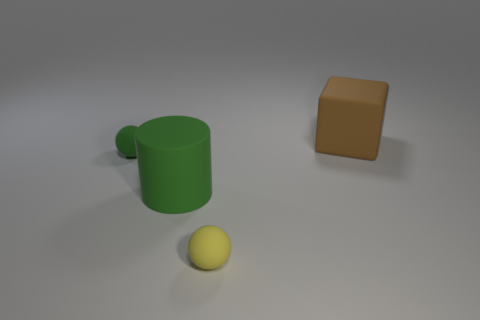What is the shape of the thing that is the same color as the matte cylinder?
Provide a succinct answer. Sphere. Are there any other tiny objects of the same shape as the small yellow rubber thing?
Your response must be concise. Yes. What is the shape of the thing that is the same size as the yellow sphere?
Make the answer very short. Sphere. There is a big cylinder; does it have the same color as the tiny matte object on the left side of the big green rubber thing?
Keep it short and to the point. Yes. There is a large matte thing left of the brown matte block; how many cubes are to the right of it?
Provide a succinct answer. 1. There is a object that is both in front of the large cube and on the right side of the large rubber cylinder; what is its size?
Offer a very short reply. Small. Are there any other spheres of the same size as the green rubber ball?
Provide a short and direct response. Yes. Is the number of cubes left of the tiny yellow ball greater than the number of yellow spheres right of the brown object?
Make the answer very short. No. Is the material of the brown cube the same as the small yellow object to the right of the big green rubber cylinder?
Keep it short and to the point. Yes. What number of balls are behind the green object that is on the right side of the rubber ball to the left of the small yellow matte object?
Ensure brevity in your answer.  1. 